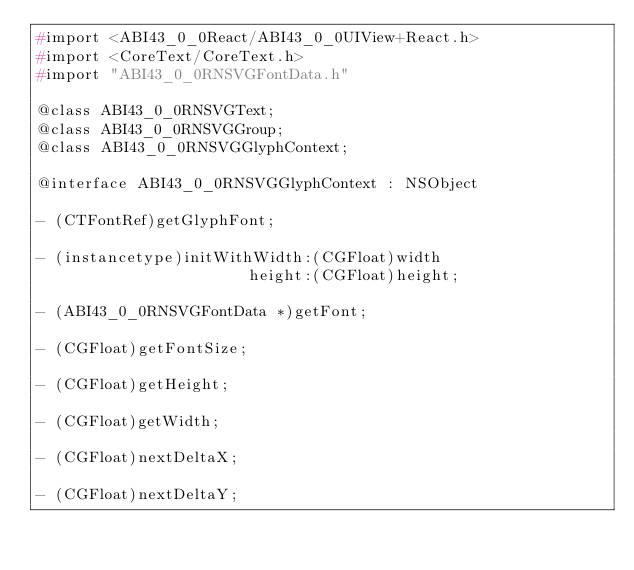<code> <loc_0><loc_0><loc_500><loc_500><_C_>#import <ABI43_0_0React/ABI43_0_0UIView+React.h>
#import <CoreText/CoreText.h>
#import "ABI43_0_0RNSVGFontData.h"

@class ABI43_0_0RNSVGText;
@class ABI43_0_0RNSVGGroup;
@class ABI43_0_0RNSVGGlyphContext;

@interface ABI43_0_0RNSVGGlyphContext : NSObject

- (CTFontRef)getGlyphFont;

- (instancetype)initWithWidth:(CGFloat)width
                       height:(CGFloat)height;

- (ABI43_0_0RNSVGFontData *)getFont;

- (CGFloat)getFontSize;

- (CGFloat)getHeight;

- (CGFloat)getWidth;

- (CGFloat)nextDeltaX;

- (CGFloat)nextDeltaY;
</code> 